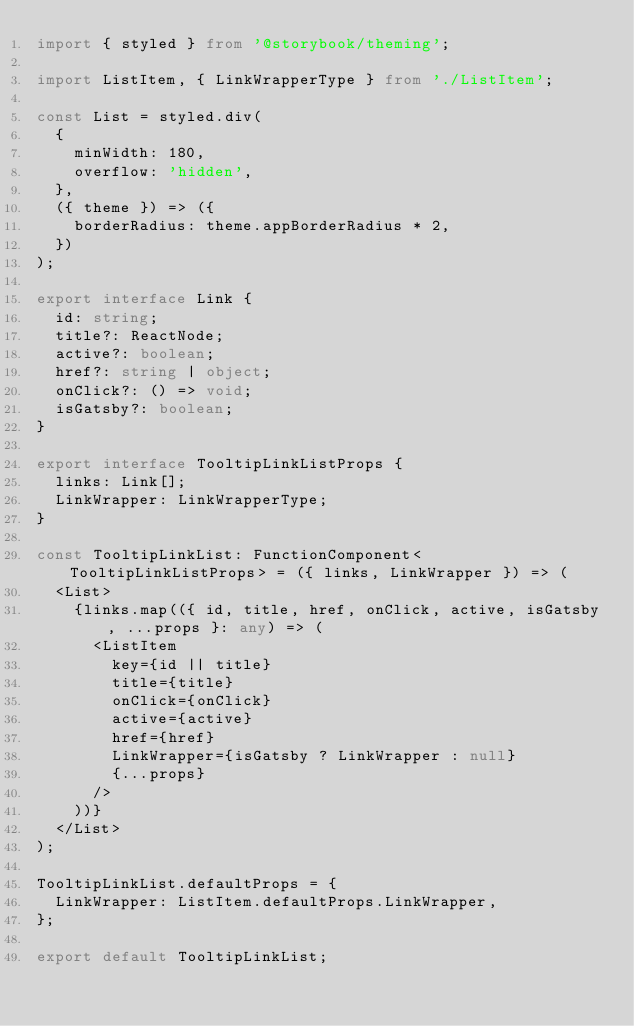Convert code to text. <code><loc_0><loc_0><loc_500><loc_500><_TypeScript_>import { styled } from '@storybook/theming';

import ListItem, { LinkWrapperType } from './ListItem';

const List = styled.div(
  {
    minWidth: 180,
    overflow: 'hidden',
  },
  ({ theme }) => ({
    borderRadius: theme.appBorderRadius * 2,
  })
);

export interface Link {
  id: string;
  title?: ReactNode;
  active?: boolean;
  href?: string | object;
  onClick?: () => void;
  isGatsby?: boolean;
}

export interface TooltipLinkListProps {
  links: Link[];
  LinkWrapper: LinkWrapperType;
}

const TooltipLinkList: FunctionComponent<TooltipLinkListProps> = ({ links, LinkWrapper }) => (
  <List>
    {links.map(({ id, title, href, onClick, active, isGatsby, ...props }: any) => (
      <ListItem
        key={id || title}
        title={title}
        onClick={onClick}
        active={active}
        href={href}
        LinkWrapper={isGatsby ? LinkWrapper : null}
        {...props}
      />
    ))}
  </List>
);

TooltipLinkList.defaultProps = {
  LinkWrapper: ListItem.defaultProps.LinkWrapper,
};

export default TooltipLinkList;
</code> 